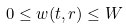Convert formula to latex. <formula><loc_0><loc_0><loc_500><loc_500>0 \leq w ( t , r ) \leq W</formula> 